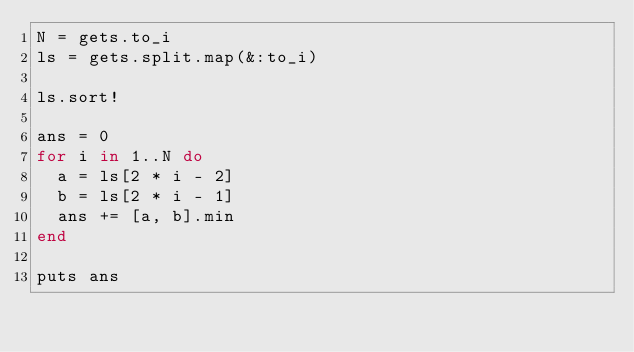<code> <loc_0><loc_0><loc_500><loc_500><_Ruby_>N = gets.to_i
ls = gets.split.map(&:to_i)

ls.sort!

ans = 0
for i in 1..N do
  a = ls[2 * i - 2]
  b = ls[2 * i - 1]
  ans += [a, b].min
end

puts ans</code> 